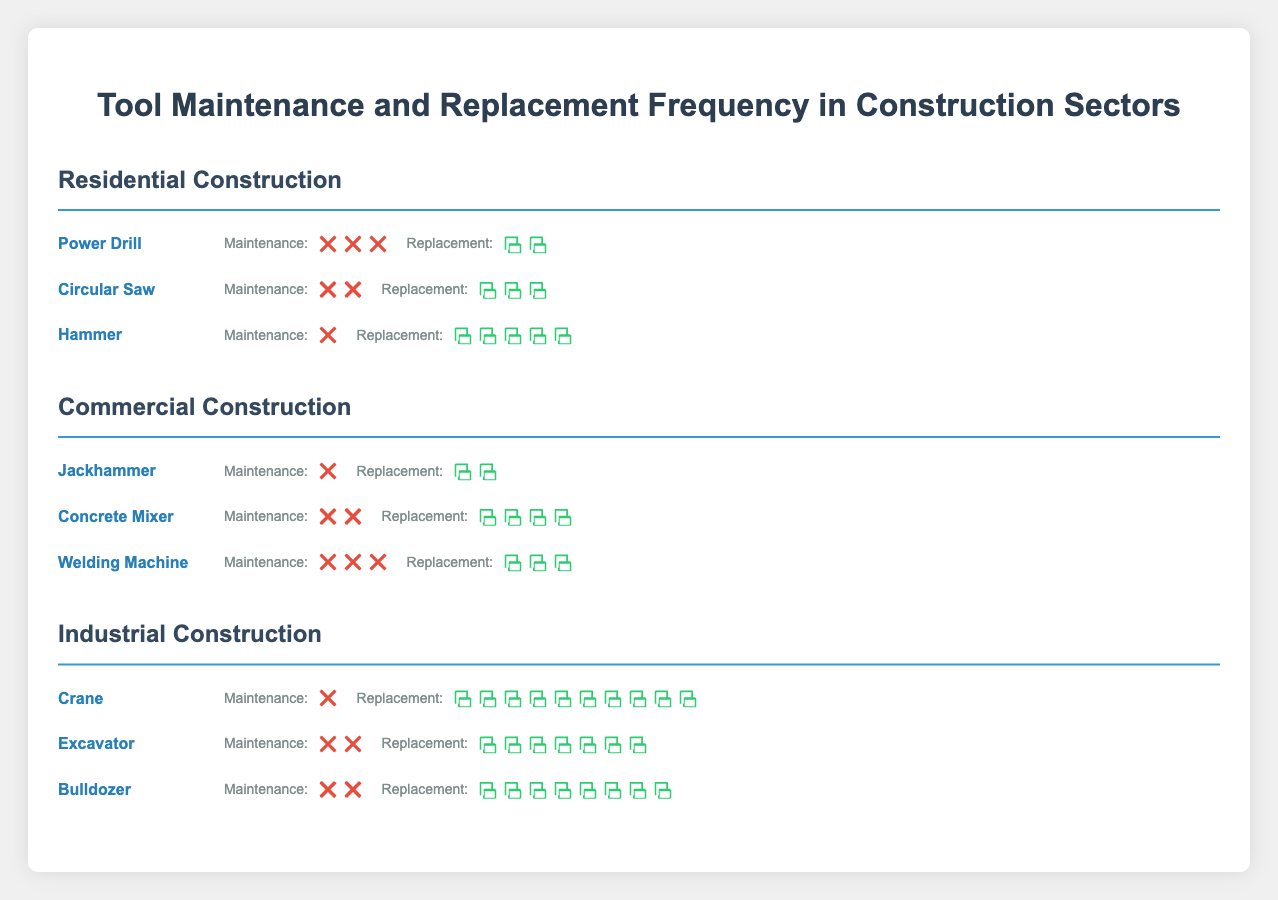What's the title of the plot? The title is at the top of the figure, centered and in large text.
Answer: Tool Maintenance and Replacement Frequency in Construction Sectors Which sector has a tool with the highest replacement frequency? The tool with the highest replacement frequency is the Crane in the Industrial Construction sector with a replacement frequency of 120 months.
Answer: Industrial Construction How often does a Circular Saw need to be maintained compared to a Concrete Mixer? The Residential Construction sector's Circular Saw is maintained every 2 months while the Commercial Construction sector's Concrete Mixer is also maintained every 2 months, indicating they are maintained at the same frequency.
Answer: Same frequency In the Residential Construction sector, what is the total maintenance frequency for all tools combined? Add the maintenance frequencies of all tools in the Residential Construction sector (Power Drill: 3, Circular Saw: 2, Hammer: 1). 3 + 2 + 1 = 6 months.
Answer: 6 months Which sector has the most variety of tools listed? Count the number of tools listed in each sector. All sectors have exactly three tools listed.
Answer: All sectors What's the average replacement frequency of tools in the Commercial Construction sector? Add the replacement frequencies of the tools in the Commercial Construction sector (Jackhammer: 18, Concrete Mixer: 48, Welding Machine: 36), then divide by the number of tools, which is 3. Average = (18 + 48 + 36) / 3 = 34 months.
Answer: 34 months Which tool requires the least maintenance in the Industrial Construction sector? The maintenance frequency of the tools in the Industrial Construction sector are Crane: 1, Excavator: 2, and Bulldozer: 2. The Crane has the least frequent maintenance of 1 month.
Answer: Crane Are there any tools in different sectors with the same replacement frequency? Comparing replacement frequencies across sectors: Circular Saw (Residential) and Welding Machine (Commercial) both have a replacement frequency of 36 months.
Answer: Yes How frequently is the Power Drill replaced in the Residential Construction sector? Refer to the specific tool's data within the Residential Construction sector. The Power Drill is replaced every 24 months.
Answer: Every 24 months Which sector has tools with more frequent maintenance overall, Residential or Industrial Construction? Add the maintenance frequencies of all tools in each sector. Residential (3 + 2 + 1) = 6; Industrial (1 + 2 + 2) = 5. The Residential Construction sector has more frequent overall maintenance.
Answer: Residential Construction 